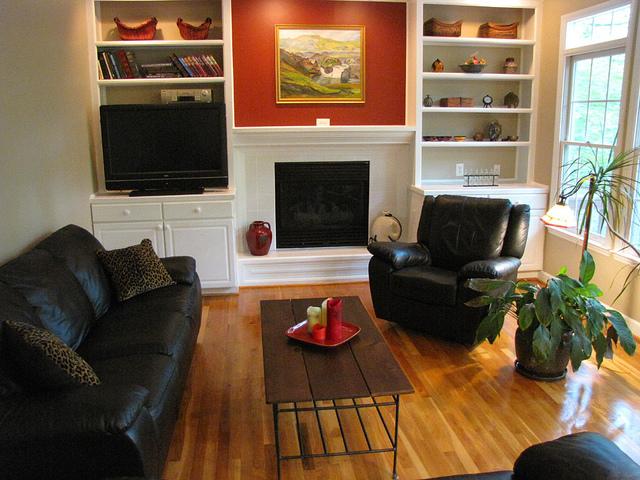What is the picture in the background?
Give a very brief answer. Landscape. What room is this?
Keep it brief. Living room. What color are the couches?
Short answer required. Black. 